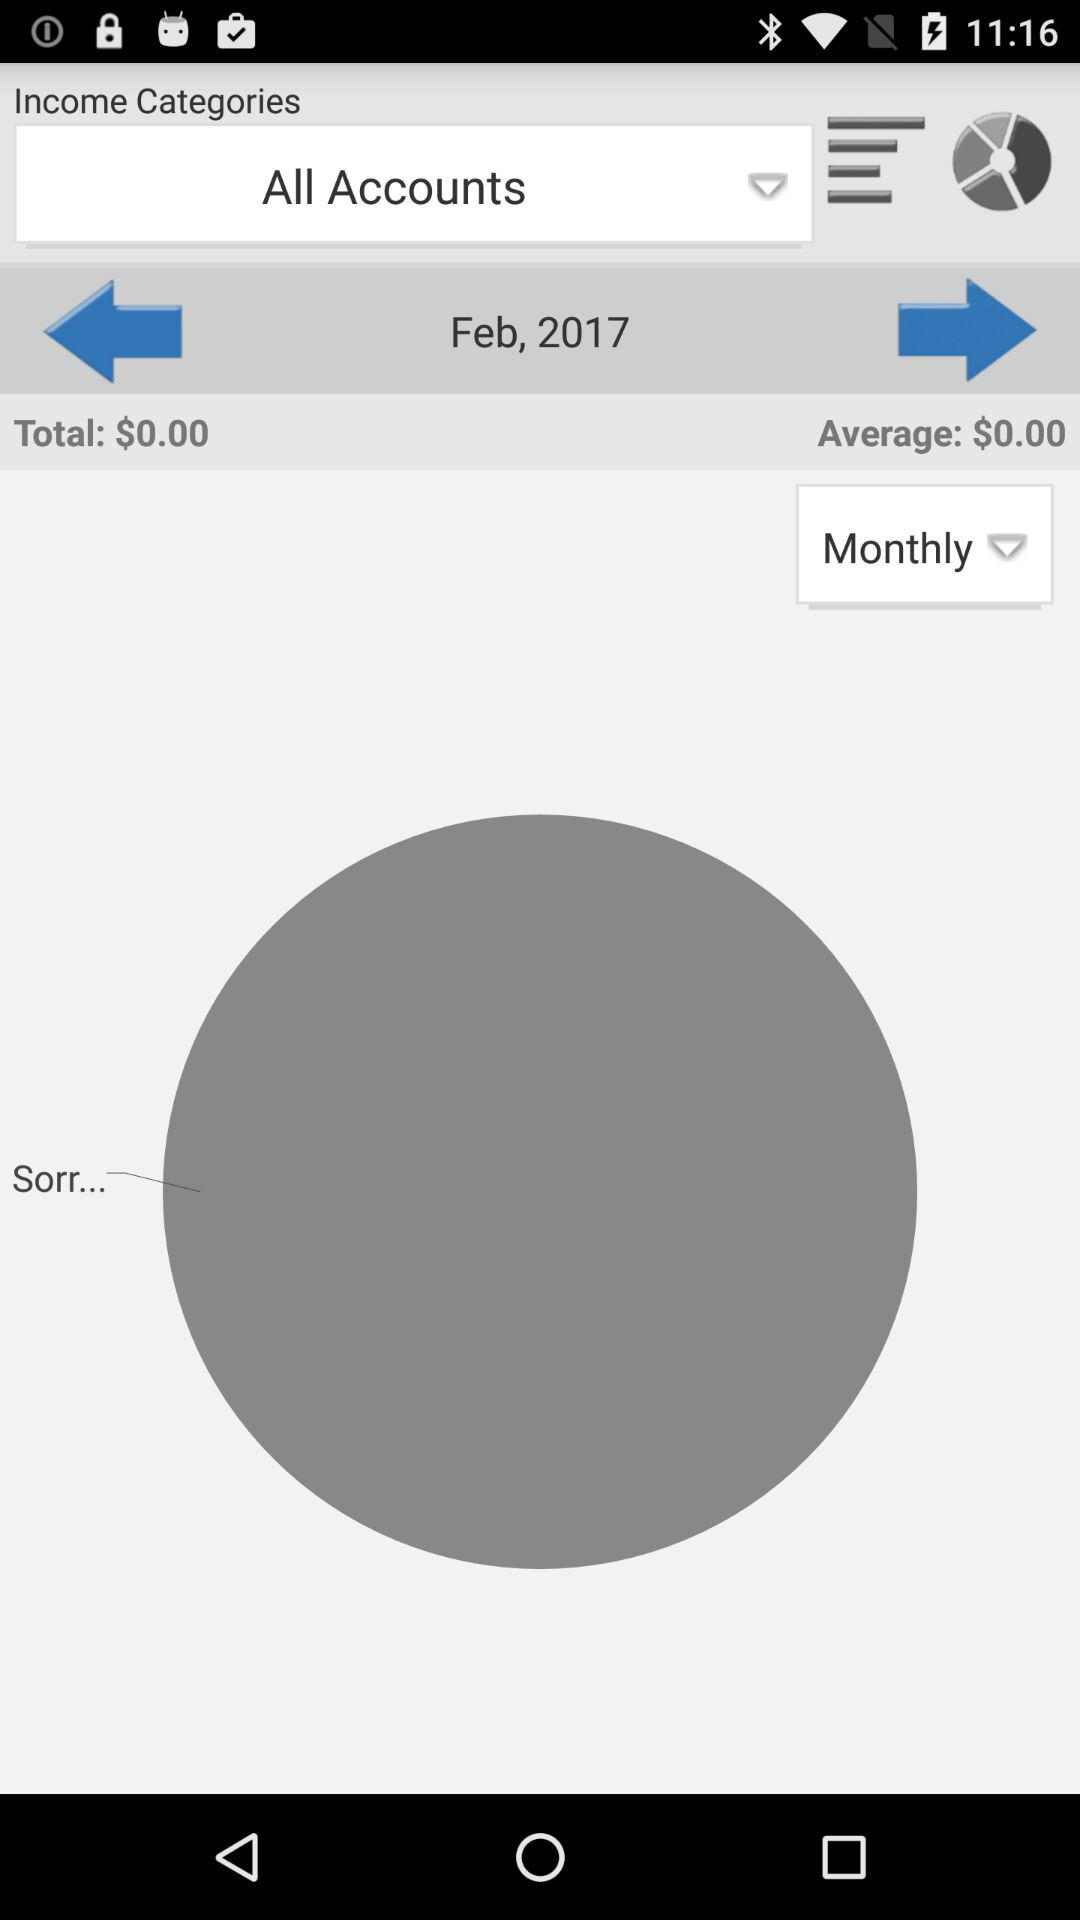What month is given? The month is February. 